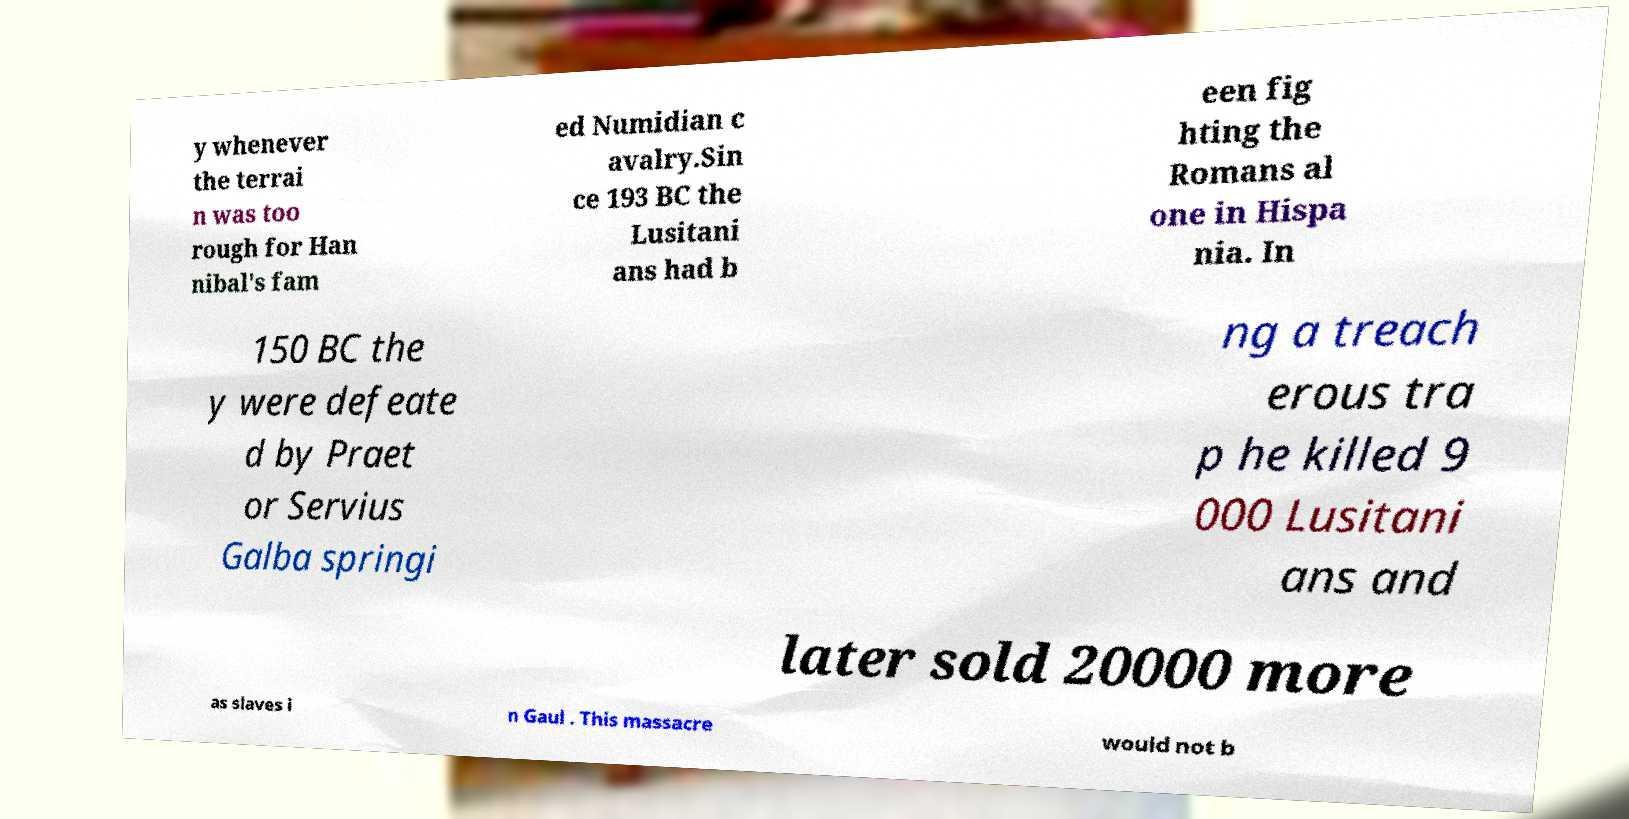Can you accurately transcribe the text from the provided image for me? y whenever the terrai n was too rough for Han nibal's fam ed Numidian c avalry.Sin ce 193 BC the Lusitani ans had b een fig hting the Romans al one in Hispa nia. In 150 BC the y were defeate d by Praet or Servius Galba springi ng a treach erous tra p he killed 9 000 Lusitani ans and later sold 20000 more as slaves i n Gaul . This massacre would not b 